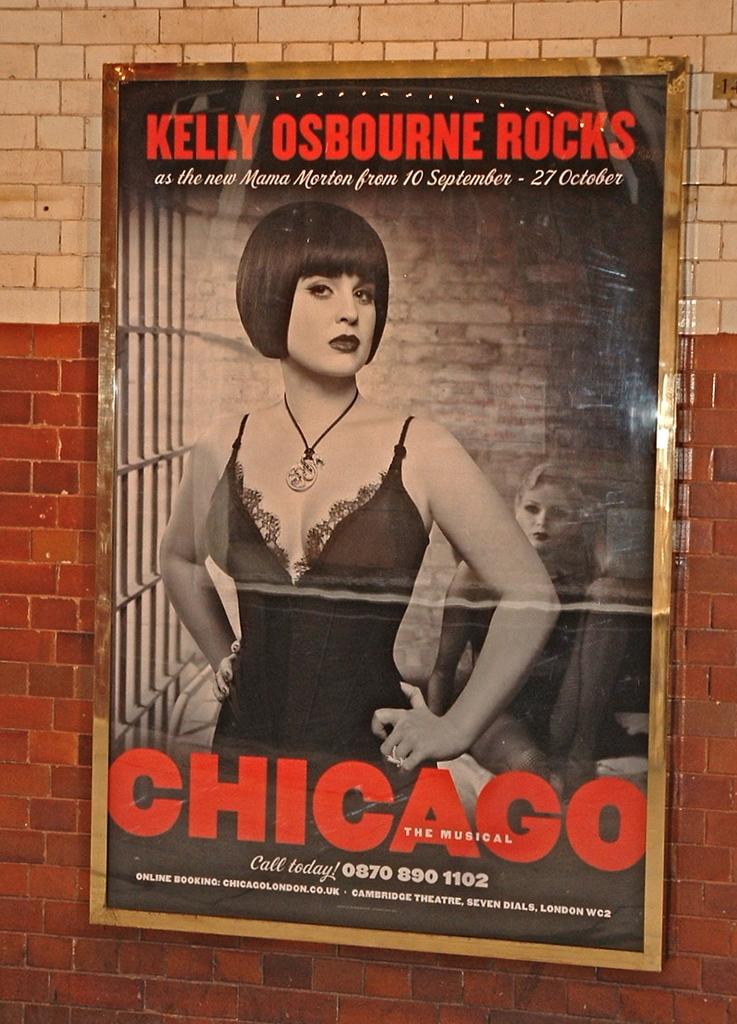What is the name of the play?
Ensure brevity in your answer.  Chicago. What city is shown on this picture?
Offer a very short reply. Chicago. 